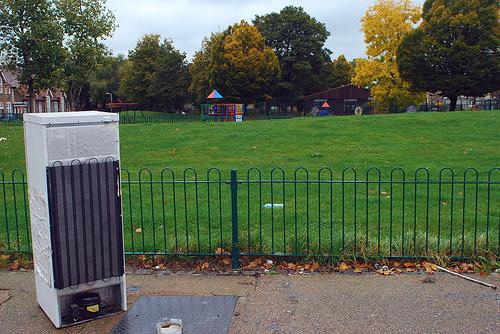Question: why did this picture get taken?
Choices:
A. It was taken to show the machine.
B. It was taken to show the car.
C. It was taken to show the boat.
D. It was taken to show the motorcycle.
Answer with the letter. Answer: A Question: how does the sky look?
Choices:
A. The sky is bright and clear.
B. The sky is dark and cloudy.
C. The sky is bright and cloudy.
D. The sky is dark and clear.
Answer with the letter. Answer: B Question: who is standing next to the machine?
Choices:
A. The salesman is standing next to the machine.
B. The delivery guy is standing next to the machine.
C. Nobody is standing next to the machine.
D. The repair tech is standing next to the machine.
Answer with the letter. Answer: C Question: what color is the machine?
Choices:
A. The machine is red.
B. The machine is black.
C. The machine is white.
D. The machine is blue.
Answer with the letter. Answer: C 